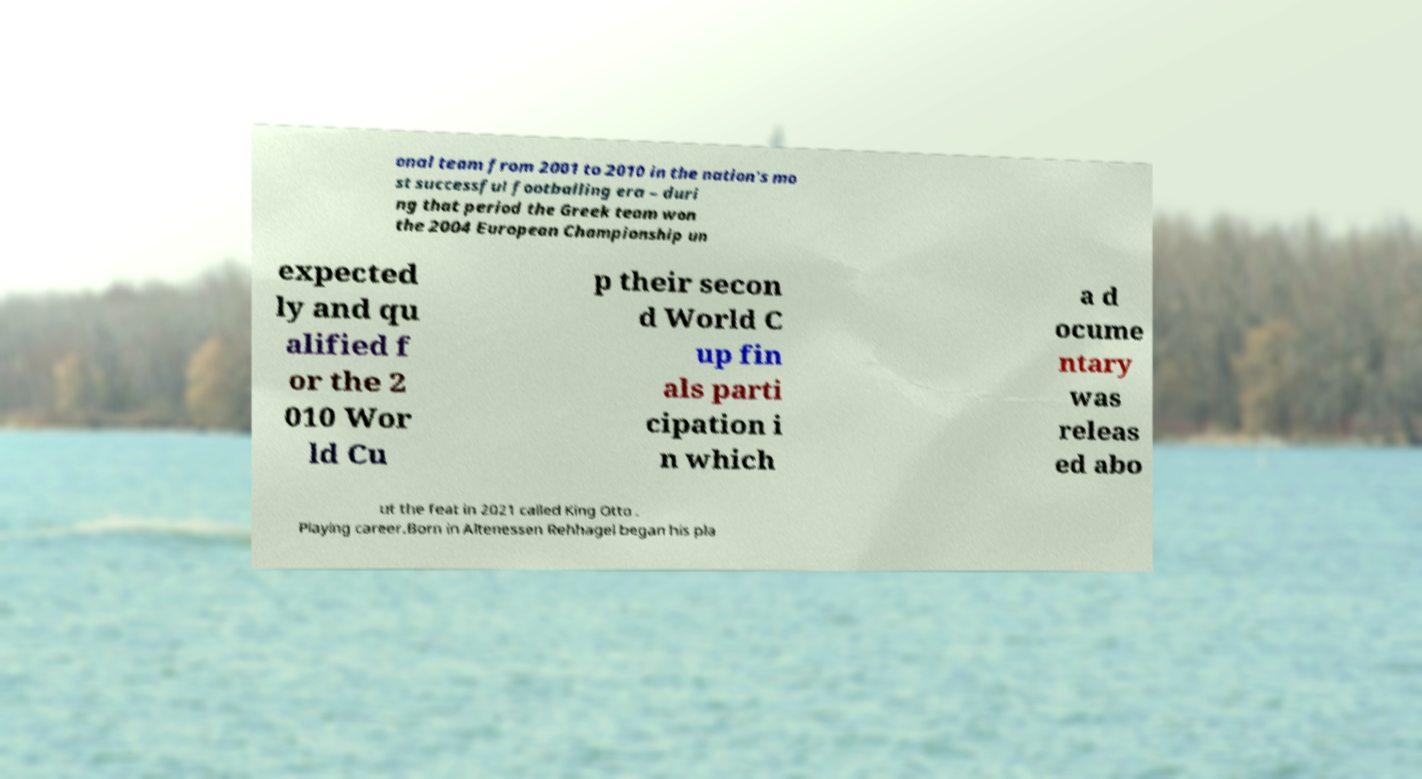What messages or text are displayed in this image? I need them in a readable, typed format. onal team from 2001 to 2010 in the nation's mo st successful footballing era – duri ng that period the Greek team won the 2004 European Championship un expected ly and qu alified f or the 2 010 Wor ld Cu p their secon d World C up fin als parti cipation i n which a d ocume ntary was releas ed abo ut the feat in 2021 called King Otto . Playing career.Born in Altenessen Rehhagel began his pla 